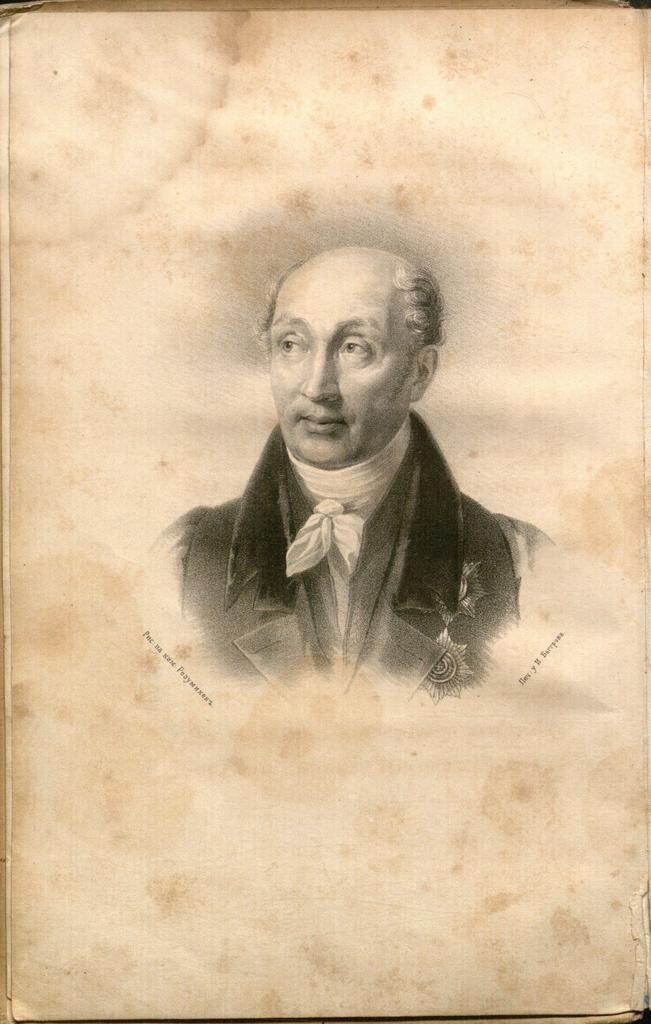What is the main subject of the image? The main subject of the image is a paper. What is depicted on the paper? The paper has an image of a man. Where is the desk located in the image? There is no desk present in the image; it only features a paper with an image of a man. What type of trade is being conducted in the image? There is no trade being conducted in the image; it only features a paper with an image of a man. 